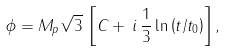<formula> <loc_0><loc_0><loc_500><loc_500>\phi = M _ { p } \sqrt { 3 } \, \left [ C + \, i \, \frac { 1 } { 3 } \ln \left ( t / t _ { 0 } \right ) \right ] ,</formula> 